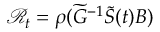Convert formula to latex. <formula><loc_0><loc_0><loc_500><loc_500>\mathcal { R } _ { t } = \rho ( \widetilde { G } ^ { - 1 } \widetilde { S } ( t ) B )</formula> 